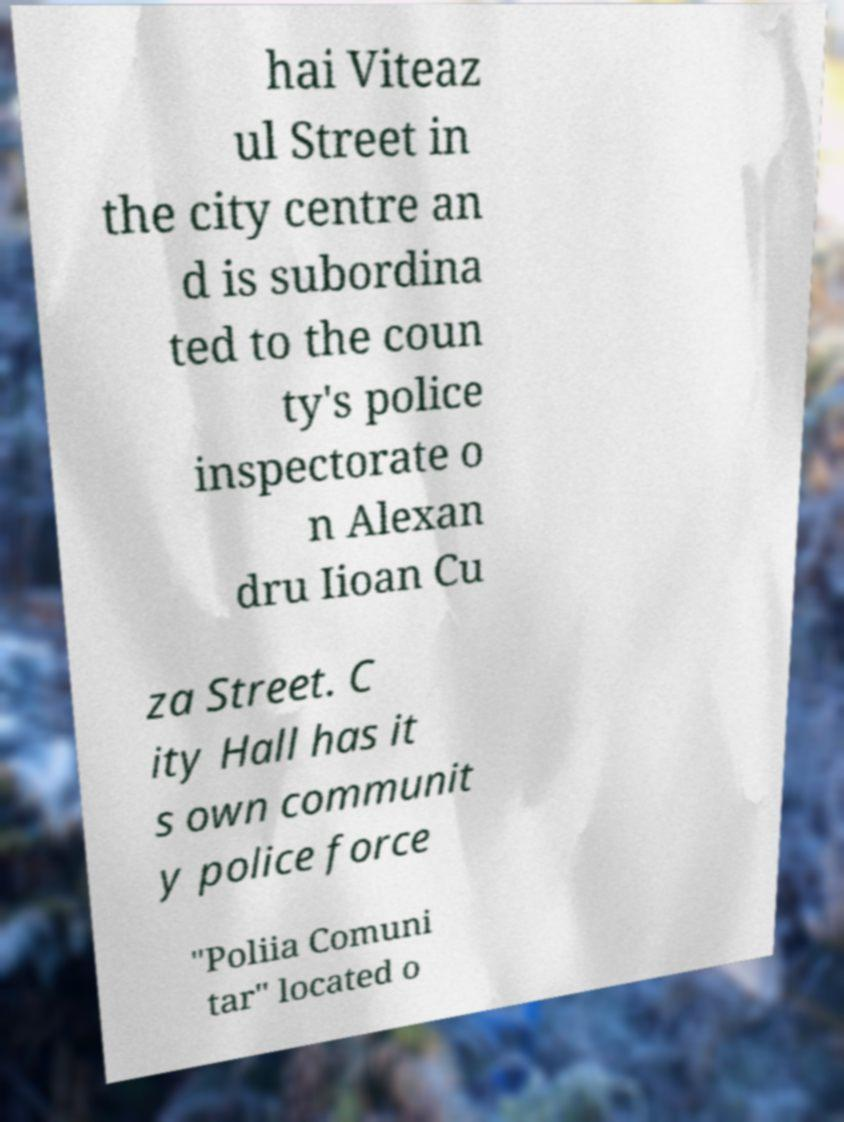Please read and relay the text visible in this image. What does it say? hai Viteaz ul Street in the city centre an d is subordina ted to the coun ty's police inspectorate o n Alexan dru Iioan Cu za Street. C ity Hall has it s own communit y police force "Poliia Comuni tar" located o 